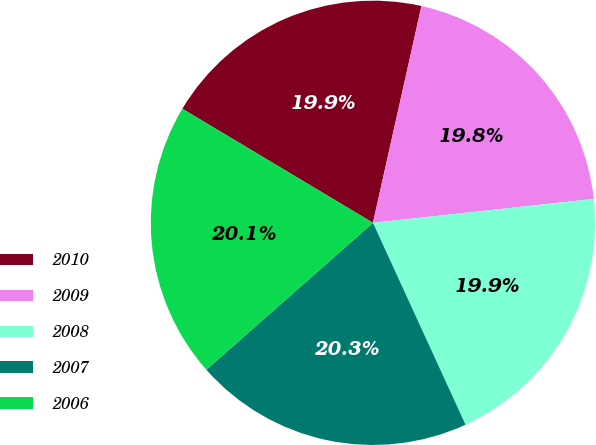Convert chart. <chart><loc_0><loc_0><loc_500><loc_500><pie_chart><fcel>2010<fcel>2009<fcel>2008<fcel>2007<fcel>2006<nl><fcel>19.92%<fcel>19.78%<fcel>19.87%<fcel>20.34%<fcel>20.08%<nl></chart> 